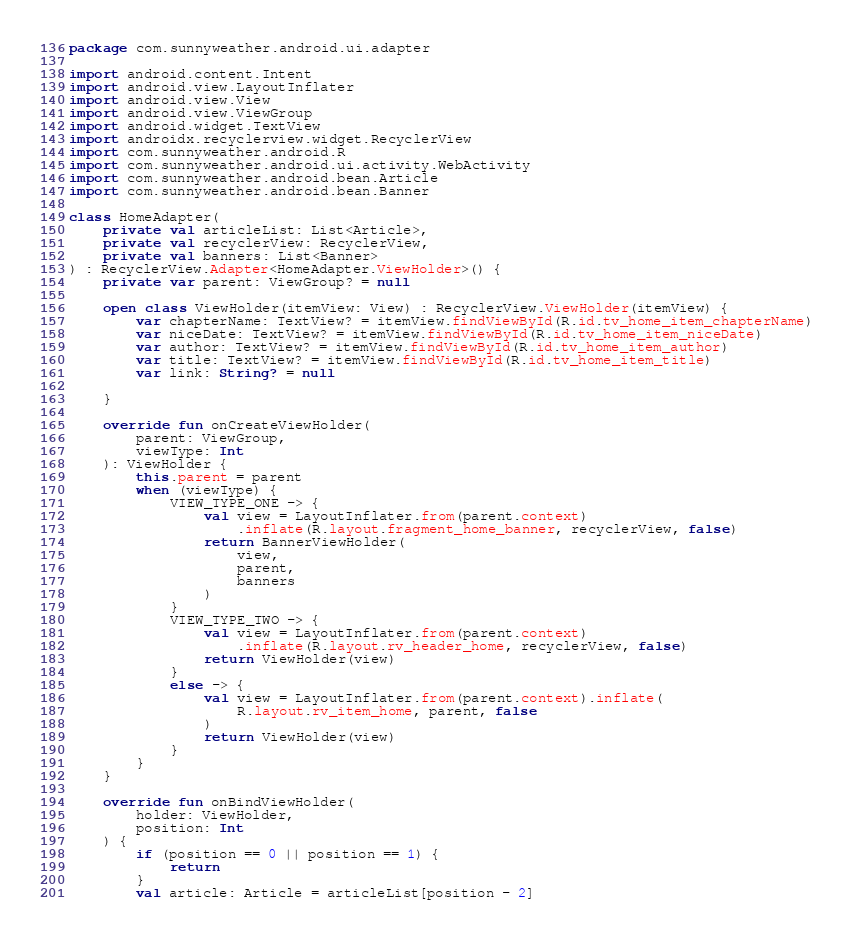Convert code to text. <code><loc_0><loc_0><loc_500><loc_500><_Kotlin_>package com.sunnyweather.android.ui.adapter

import android.content.Intent
import android.view.LayoutInflater
import android.view.View
import android.view.ViewGroup
import android.widget.TextView
import androidx.recyclerview.widget.RecyclerView
import com.sunnyweather.android.R
import com.sunnyweather.android.ui.activity.WebActivity
import com.sunnyweather.android.bean.Article
import com.sunnyweather.android.bean.Banner

class HomeAdapter(
    private val articleList: List<Article>,
    private val recyclerView: RecyclerView,
    private val banners: List<Banner>
) : RecyclerView.Adapter<HomeAdapter.ViewHolder>() {
    private var parent: ViewGroup? = null

    open class ViewHolder(itemView: View) : RecyclerView.ViewHolder(itemView) {
        var chapterName: TextView? = itemView.findViewById(R.id.tv_home_item_chapterName)
        var niceDate: TextView? = itemView.findViewById(R.id.tv_home_item_niceDate)
        var author: TextView? = itemView.findViewById(R.id.tv_home_item_author)
        var title: TextView? = itemView.findViewById(R.id.tv_home_item_title)
        var link: String? = null

    }

    override fun onCreateViewHolder(
        parent: ViewGroup,
        viewType: Int
    ): ViewHolder {
        this.parent = parent
        when (viewType) {
            VIEW_TYPE_ONE -> {
                val view = LayoutInflater.from(parent.context)
                    .inflate(R.layout.fragment_home_banner, recyclerView, false)
                return BannerViewHolder(
                    view,
                    parent,
                    banners
                )
            }
            VIEW_TYPE_TWO -> {
                val view = LayoutInflater.from(parent.context)
                    .inflate(R.layout.rv_header_home, recyclerView, false)
                return ViewHolder(view)
            }
            else -> {
                val view = LayoutInflater.from(parent.context).inflate(
                    R.layout.rv_item_home, parent, false
                )
                return ViewHolder(view)
            }
        }
    }

    override fun onBindViewHolder(
        holder: ViewHolder,
        position: Int
    ) {
        if (position == 0 || position == 1) {
            return
        }
        val article: Article = articleList[position - 2]</code> 